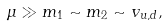<formula> <loc_0><loc_0><loc_500><loc_500>\mu \gg m _ { 1 } \sim m _ { 2 } \sim v _ { u , d } ,</formula> 